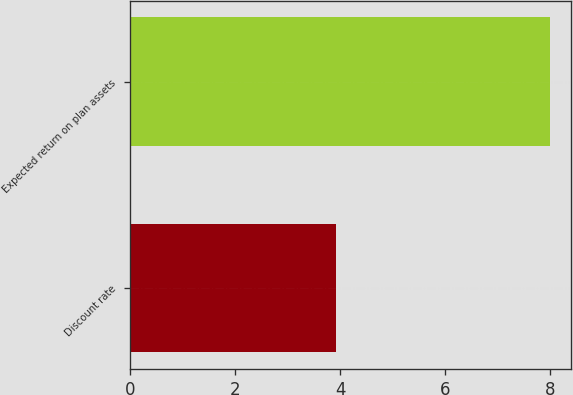Convert chart to OTSL. <chart><loc_0><loc_0><loc_500><loc_500><bar_chart><fcel>Discount rate<fcel>Expected return on plan assets<nl><fcel>3.93<fcel>8<nl></chart> 